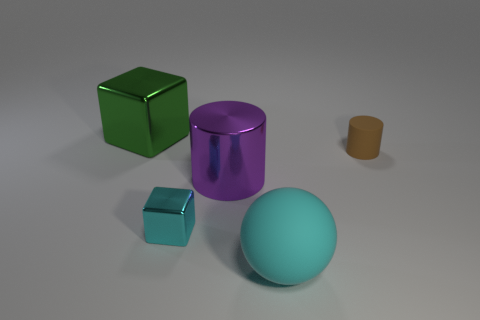Add 1 cyan matte balls. How many objects exist? 6 Add 5 cyan shiny cubes. How many cyan shiny cubes exist? 6 Subtract all brown cylinders. How many cylinders are left? 1 Subtract 1 brown cylinders. How many objects are left? 4 Subtract all cylinders. How many objects are left? 3 Subtract all yellow cylinders. Subtract all purple cubes. How many cylinders are left? 2 Subtract all gray balls. How many green cubes are left? 1 Subtract all cyan metal blocks. Subtract all blue blocks. How many objects are left? 4 Add 1 big metallic cylinders. How many big metallic cylinders are left? 2 